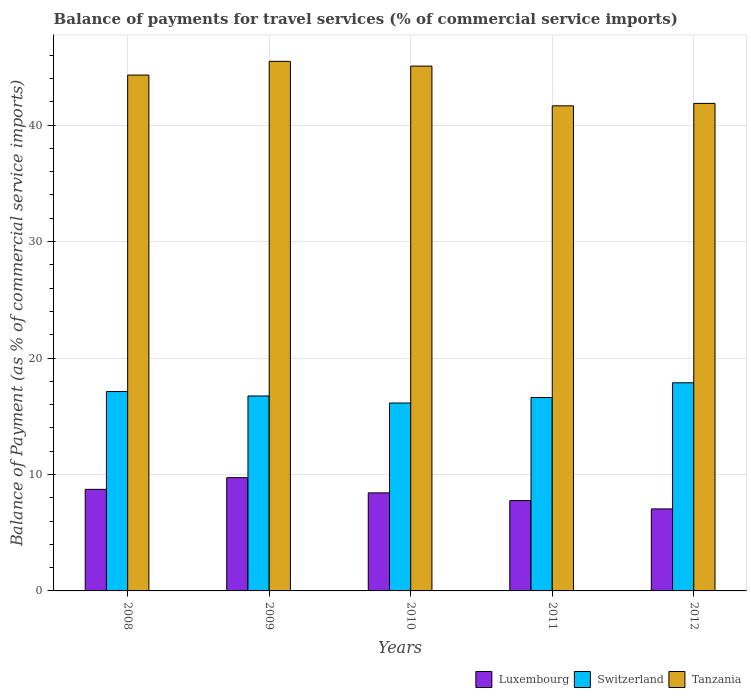How many different coloured bars are there?
Your answer should be very brief. 3. How many groups of bars are there?
Make the answer very short. 5. Are the number of bars on each tick of the X-axis equal?
Keep it short and to the point. Yes. How many bars are there on the 1st tick from the right?
Ensure brevity in your answer.  3. What is the label of the 3rd group of bars from the left?
Your answer should be compact. 2010. In how many cases, is the number of bars for a given year not equal to the number of legend labels?
Give a very brief answer. 0. What is the balance of payments for travel services in Switzerland in 2010?
Give a very brief answer. 16.14. Across all years, what is the maximum balance of payments for travel services in Tanzania?
Your answer should be very brief. 45.48. Across all years, what is the minimum balance of payments for travel services in Luxembourg?
Keep it short and to the point. 7.04. In which year was the balance of payments for travel services in Luxembourg maximum?
Your response must be concise. 2009. In which year was the balance of payments for travel services in Tanzania minimum?
Ensure brevity in your answer.  2011. What is the total balance of payments for travel services in Tanzania in the graph?
Make the answer very short. 218.37. What is the difference between the balance of payments for travel services in Tanzania in 2008 and that in 2011?
Your answer should be compact. 2.64. What is the difference between the balance of payments for travel services in Switzerland in 2010 and the balance of payments for travel services in Tanzania in 2012?
Make the answer very short. -25.73. What is the average balance of payments for travel services in Luxembourg per year?
Your response must be concise. 8.33. In the year 2011, what is the difference between the balance of payments for travel services in Luxembourg and balance of payments for travel services in Tanzania?
Provide a short and direct response. -33.9. In how many years, is the balance of payments for travel services in Switzerland greater than 6 %?
Offer a terse response. 5. What is the ratio of the balance of payments for travel services in Switzerland in 2008 to that in 2010?
Your answer should be very brief. 1.06. Is the balance of payments for travel services in Switzerland in 2009 less than that in 2010?
Your answer should be very brief. No. What is the difference between the highest and the second highest balance of payments for travel services in Luxembourg?
Ensure brevity in your answer.  1. What is the difference between the highest and the lowest balance of payments for travel services in Switzerland?
Your response must be concise. 1.74. In how many years, is the balance of payments for travel services in Luxembourg greater than the average balance of payments for travel services in Luxembourg taken over all years?
Provide a short and direct response. 3. Is the sum of the balance of payments for travel services in Tanzania in 2009 and 2011 greater than the maximum balance of payments for travel services in Switzerland across all years?
Give a very brief answer. Yes. What does the 2nd bar from the left in 2010 represents?
Make the answer very short. Switzerland. What does the 3rd bar from the right in 2008 represents?
Ensure brevity in your answer.  Luxembourg. Are all the bars in the graph horizontal?
Provide a succinct answer. No. How many years are there in the graph?
Offer a very short reply. 5. Are the values on the major ticks of Y-axis written in scientific E-notation?
Keep it short and to the point. No. Does the graph contain grids?
Offer a very short reply. Yes. What is the title of the graph?
Ensure brevity in your answer.  Balance of payments for travel services (% of commercial service imports). What is the label or title of the X-axis?
Make the answer very short. Years. What is the label or title of the Y-axis?
Provide a succinct answer. Balance of Payment (as % of commercial service imports). What is the Balance of Payment (as % of commercial service imports) in Luxembourg in 2008?
Keep it short and to the point. 8.72. What is the Balance of Payment (as % of commercial service imports) of Switzerland in 2008?
Offer a very short reply. 17.12. What is the Balance of Payment (as % of commercial service imports) in Tanzania in 2008?
Your answer should be compact. 44.3. What is the Balance of Payment (as % of commercial service imports) of Luxembourg in 2009?
Provide a succinct answer. 9.73. What is the Balance of Payment (as % of commercial service imports) in Switzerland in 2009?
Your response must be concise. 16.74. What is the Balance of Payment (as % of commercial service imports) in Tanzania in 2009?
Offer a very short reply. 45.48. What is the Balance of Payment (as % of commercial service imports) of Luxembourg in 2010?
Offer a terse response. 8.42. What is the Balance of Payment (as % of commercial service imports) in Switzerland in 2010?
Give a very brief answer. 16.14. What is the Balance of Payment (as % of commercial service imports) of Tanzania in 2010?
Give a very brief answer. 45.07. What is the Balance of Payment (as % of commercial service imports) in Luxembourg in 2011?
Offer a very short reply. 7.76. What is the Balance of Payment (as % of commercial service imports) in Switzerland in 2011?
Offer a terse response. 16.61. What is the Balance of Payment (as % of commercial service imports) of Tanzania in 2011?
Ensure brevity in your answer.  41.66. What is the Balance of Payment (as % of commercial service imports) in Luxembourg in 2012?
Your answer should be compact. 7.04. What is the Balance of Payment (as % of commercial service imports) in Switzerland in 2012?
Your answer should be very brief. 17.87. What is the Balance of Payment (as % of commercial service imports) in Tanzania in 2012?
Make the answer very short. 41.87. Across all years, what is the maximum Balance of Payment (as % of commercial service imports) of Luxembourg?
Offer a very short reply. 9.73. Across all years, what is the maximum Balance of Payment (as % of commercial service imports) of Switzerland?
Offer a terse response. 17.87. Across all years, what is the maximum Balance of Payment (as % of commercial service imports) of Tanzania?
Your answer should be very brief. 45.48. Across all years, what is the minimum Balance of Payment (as % of commercial service imports) of Luxembourg?
Give a very brief answer. 7.04. Across all years, what is the minimum Balance of Payment (as % of commercial service imports) in Switzerland?
Make the answer very short. 16.14. Across all years, what is the minimum Balance of Payment (as % of commercial service imports) in Tanzania?
Keep it short and to the point. 41.66. What is the total Balance of Payment (as % of commercial service imports) of Luxembourg in the graph?
Your response must be concise. 41.67. What is the total Balance of Payment (as % of commercial service imports) in Switzerland in the graph?
Ensure brevity in your answer.  84.48. What is the total Balance of Payment (as % of commercial service imports) in Tanzania in the graph?
Your answer should be very brief. 218.37. What is the difference between the Balance of Payment (as % of commercial service imports) of Luxembourg in 2008 and that in 2009?
Give a very brief answer. -1. What is the difference between the Balance of Payment (as % of commercial service imports) of Switzerland in 2008 and that in 2009?
Offer a terse response. 0.38. What is the difference between the Balance of Payment (as % of commercial service imports) of Tanzania in 2008 and that in 2009?
Make the answer very short. -1.18. What is the difference between the Balance of Payment (as % of commercial service imports) of Luxembourg in 2008 and that in 2010?
Your answer should be compact. 0.3. What is the difference between the Balance of Payment (as % of commercial service imports) in Switzerland in 2008 and that in 2010?
Make the answer very short. 0.98. What is the difference between the Balance of Payment (as % of commercial service imports) in Tanzania in 2008 and that in 2010?
Make the answer very short. -0.77. What is the difference between the Balance of Payment (as % of commercial service imports) of Luxembourg in 2008 and that in 2011?
Offer a very short reply. 0.96. What is the difference between the Balance of Payment (as % of commercial service imports) in Switzerland in 2008 and that in 2011?
Your answer should be very brief. 0.51. What is the difference between the Balance of Payment (as % of commercial service imports) of Tanzania in 2008 and that in 2011?
Your answer should be compact. 2.64. What is the difference between the Balance of Payment (as % of commercial service imports) of Luxembourg in 2008 and that in 2012?
Provide a short and direct response. 1.68. What is the difference between the Balance of Payment (as % of commercial service imports) in Switzerland in 2008 and that in 2012?
Provide a short and direct response. -0.75. What is the difference between the Balance of Payment (as % of commercial service imports) of Tanzania in 2008 and that in 2012?
Your answer should be very brief. 2.43. What is the difference between the Balance of Payment (as % of commercial service imports) of Luxembourg in 2009 and that in 2010?
Your answer should be very brief. 1.31. What is the difference between the Balance of Payment (as % of commercial service imports) of Switzerland in 2009 and that in 2010?
Your answer should be very brief. 0.6. What is the difference between the Balance of Payment (as % of commercial service imports) in Tanzania in 2009 and that in 2010?
Ensure brevity in your answer.  0.41. What is the difference between the Balance of Payment (as % of commercial service imports) in Luxembourg in 2009 and that in 2011?
Your response must be concise. 1.97. What is the difference between the Balance of Payment (as % of commercial service imports) in Switzerland in 2009 and that in 2011?
Your response must be concise. 0.13. What is the difference between the Balance of Payment (as % of commercial service imports) of Tanzania in 2009 and that in 2011?
Keep it short and to the point. 3.82. What is the difference between the Balance of Payment (as % of commercial service imports) of Luxembourg in 2009 and that in 2012?
Ensure brevity in your answer.  2.68. What is the difference between the Balance of Payment (as % of commercial service imports) of Switzerland in 2009 and that in 2012?
Your answer should be very brief. -1.13. What is the difference between the Balance of Payment (as % of commercial service imports) of Tanzania in 2009 and that in 2012?
Provide a short and direct response. 3.61. What is the difference between the Balance of Payment (as % of commercial service imports) in Luxembourg in 2010 and that in 2011?
Ensure brevity in your answer.  0.66. What is the difference between the Balance of Payment (as % of commercial service imports) in Switzerland in 2010 and that in 2011?
Ensure brevity in your answer.  -0.47. What is the difference between the Balance of Payment (as % of commercial service imports) in Tanzania in 2010 and that in 2011?
Your answer should be very brief. 3.41. What is the difference between the Balance of Payment (as % of commercial service imports) of Luxembourg in 2010 and that in 2012?
Give a very brief answer. 1.38. What is the difference between the Balance of Payment (as % of commercial service imports) of Switzerland in 2010 and that in 2012?
Offer a very short reply. -1.74. What is the difference between the Balance of Payment (as % of commercial service imports) in Tanzania in 2010 and that in 2012?
Ensure brevity in your answer.  3.2. What is the difference between the Balance of Payment (as % of commercial service imports) in Luxembourg in 2011 and that in 2012?
Provide a short and direct response. 0.72. What is the difference between the Balance of Payment (as % of commercial service imports) of Switzerland in 2011 and that in 2012?
Offer a very short reply. -1.26. What is the difference between the Balance of Payment (as % of commercial service imports) of Tanzania in 2011 and that in 2012?
Your response must be concise. -0.21. What is the difference between the Balance of Payment (as % of commercial service imports) in Luxembourg in 2008 and the Balance of Payment (as % of commercial service imports) in Switzerland in 2009?
Offer a terse response. -8.02. What is the difference between the Balance of Payment (as % of commercial service imports) in Luxembourg in 2008 and the Balance of Payment (as % of commercial service imports) in Tanzania in 2009?
Your response must be concise. -36.75. What is the difference between the Balance of Payment (as % of commercial service imports) of Switzerland in 2008 and the Balance of Payment (as % of commercial service imports) of Tanzania in 2009?
Your response must be concise. -28.36. What is the difference between the Balance of Payment (as % of commercial service imports) of Luxembourg in 2008 and the Balance of Payment (as % of commercial service imports) of Switzerland in 2010?
Provide a succinct answer. -7.42. What is the difference between the Balance of Payment (as % of commercial service imports) of Luxembourg in 2008 and the Balance of Payment (as % of commercial service imports) of Tanzania in 2010?
Your answer should be very brief. -36.35. What is the difference between the Balance of Payment (as % of commercial service imports) of Switzerland in 2008 and the Balance of Payment (as % of commercial service imports) of Tanzania in 2010?
Ensure brevity in your answer.  -27.95. What is the difference between the Balance of Payment (as % of commercial service imports) of Luxembourg in 2008 and the Balance of Payment (as % of commercial service imports) of Switzerland in 2011?
Your answer should be compact. -7.89. What is the difference between the Balance of Payment (as % of commercial service imports) in Luxembourg in 2008 and the Balance of Payment (as % of commercial service imports) in Tanzania in 2011?
Keep it short and to the point. -32.94. What is the difference between the Balance of Payment (as % of commercial service imports) of Switzerland in 2008 and the Balance of Payment (as % of commercial service imports) of Tanzania in 2011?
Your answer should be compact. -24.54. What is the difference between the Balance of Payment (as % of commercial service imports) of Luxembourg in 2008 and the Balance of Payment (as % of commercial service imports) of Switzerland in 2012?
Your answer should be very brief. -9.15. What is the difference between the Balance of Payment (as % of commercial service imports) in Luxembourg in 2008 and the Balance of Payment (as % of commercial service imports) in Tanzania in 2012?
Provide a succinct answer. -33.14. What is the difference between the Balance of Payment (as % of commercial service imports) in Switzerland in 2008 and the Balance of Payment (as % of commercial service imports) in Tanzania in 2012?
Give a very brief answer. -24.75. What is the difference between the Balance of Payment (as % of commercial service imports) in Luxembourg in 2009 and the Balance of Payment (as % of commercial service imports) in Switzerland in 2010?
Offer a terse response. -6.41. What is the difference between the Balance of Payment (as % of commercial service imports) of Luxembourg in 2009 and the Balance of Payment (as % of commercial service imports) of Tanzania in 2010?
Provide a short and direct response. -35.34. What is the difference between the Balance of Payment (as % of commercial service imports) in Switzerland in 2009 and the Balance of Payment (as % of commercial service imports) in Tanzania in 2010?
Make the answer very short. -28.33. What is the difference between the Balance of Payment (as % of commercial service imports) in Luxembourg in 2009 and the Balance of Payment (as % of commercial service imports) in Switzerland in 2011?
Give a very brief answer. -6.88. What is the difference between the Balance of Payment (as % of commercial service imports) in Luxembourg in 2009 and the Balance of Payment (as % of commercial service imports) in Tanzania in 2011?
Your answer should be very brief. -31.93. What is the difference between the Balance of Payment (as % of commercial service imports) in Switzerland in 2009 and the Balance of Payment (as % of commercial service imports) in Tanzania in 2011?
Give a very brief answer. -24.92. What is the difference between the Balance of Payment (as % of commercial service imports) in Luxembourg in 2009 and the Balance of Payment (as % of commercial service imports) in Switzerland in 2012?
Offer a very short reply. -8.15. What is the difference between the Balance of Payment (as % of commercial service imports) of Luxembourg in 2009 and the Balance of Payment (as % of commercial service imports) of Tanzania in 2012?
Offer a terse response. -32.14. What is the difference between the Balance of Payment (as % of commercial service imports) in Switzerland in 2009 and the Balance of Payment (as % of commercial service imports) in Tanzania in 2012?
Provide a short and direct response. -25.13. What is the difference between the Balance of Payment (as % of commercial service imports) of Luxembourg in 2010 and the Balance of Payment (as % of commercial service imports) of Switzerland in 2011?
Give a very brief answer. -8.19. What is the difference between the Balance of Payment (as % of commercial service imports) in Luxembourg in 2010 and the Balance of Payment (as % of commercial service imports) in Tanzania in 2011?
Keep it short and to the point. -33.24. What is the difference between the Balance of Payment (as % of commercial service imports) in Switzerland in 2010 and the Balance of Payment (as % of commercial service imports) in Tanzania in 2011?
Make the answer very short. -25.52. What is the difference between the Balance of Payment (as % of commercial service imports) of Luxembourg in 2010 and the Balance of Payment (as % of commercial service imports) of Switzerland in 2012?
Give a very brief answer. -9.45. What is the difference between the Balance of Payment (as % of commercial service imports) in Luxembourg in 2010 and the Balance of Payment (as % of commercial service imports) in Tanzania in 2012?
Ensure brevity in your answer.  -33.45. What is the difference between the Balance of Payment (as % of commercial service imports) of Switzerland in 2010 and the Balance of Payment (as % of commercial service imports) of Tanzania in 2012?
Offer a terse response. -25.73. What is the difference between the Balance of Payment (as % of commercial service imports) in Luxembourg in 2011 and the Balance of Payment (as % of commercial service imports) in Switzerland in 2012?
Provide a succinct answer. -10.12. What is the difference between the Balance of Payment (as % of commercial service imports) of Luxembourg in 2011 and the Balance of Payment (as % of commercial service imports) of Tanzania in 2012?
Give a very brief answer. -34.11. What is the difference between the Balance of Payment (as % of commercial service imports) in Switzerland in 2011 and the Balance of Payment (as % of commercial service imports) in Tanzania in 2012?
Ensure brevity in your answer.  -25.26. What is the average Balance of Payment (as % of commercial service imports) in Luxembourg per year?
Give a very brief answer. 8.33. What is the average Balance of Payment (as % of commercial service imports) in Switzerland per year?
Your answer should be compact. 16.9. What is the average Balance of Payment (as % of commercial service imports) in Tanzania per year?
Ensure brevity in your answer.  43.67. In the year 2008, what is the difference between the Balance of Payment (as % of commercial service imports) of Luxembourg and Balance of Payment (as % of commercial service imports) of Switzerland?
Give a very brief answer. -8.4. In the year 2008, what is the difference between the Balance of Payment (as % of commercial service imports) of Luxembourg and Balance of Payment (as % of commercial service imports) of Tanzania?
Offer a very short reply. -35.58. In the year 2008, what is the difference between the Balance of Payment (as % of commercial service imports) of Switzerland and Balance of Payment (as % of commercial service imports) of Tanzania?
Your response must be concise. -27.18. In the year 2009, what is the difference between the Balance of Payment (as % of commercial service imports) of Luxembourg and Balance of Payment (as % of commercial service imports) of Switzerland?
Keep it short and to the point. -7.01. In the year 2009, what is the difference between the Balance of Payment (as % of commercial service imports) of Luxembourg and Balance of Payment (as % of commercial service imports) of Tanzania?
Make the answer very short. -35.75. In the year 2009, what is the difference between the Balance of Payment (as % of commercial service imports) of Switzerland and Balance of Payment (as % of commercial service imports) of Tanzania?
Make the answer very short. -28.74. In the year 2010, what is the difference between the Balance of Payment (as % of commercial service imports) in Luxembourg and Balance of Payment (as % of commercial service imports) in Switzerland?
Provide a succinct answer. -7.72. In the year 2010, what is the difference between the Balance of Payment (as % of commercial service imports) of Luxembourg and Balance of Payment (as % of commercial service imports) of Tanzania?
Give a very brief answer. -36.65. In the year 2010, what is the difference between the Balance of Payment (as % of commercial service imports) of Switzerland and Balance of Payment (as % of commercial service imports) of Tanzania?
Your response must be concise. -28.93. In the year 2011, what is the difference between the Balance of Payment (as % of commercial service imports) of Luxembourg and Balance of Payment (as % of commercial service imports) of Switzerland?
Keep it short and to the point. -8.85. In the year 2011, what is the difference between the Balance of Payment (as % of commercial service imports) in Luxembourg and Balance of Payment (as % of commercial service imports) in Tanzania?
Offer a very short reply. -33.9. In the year 2011, what is the difference between the Balance of Payment (as % of commercial service imports) in Switzerland and Balance of Payment (as % of commercial service imports) in Tanzania?
Make the answer very short. -25.05. In the year 2012, what is the difference between the Balance of Payment (as % of commercial service imports) in Luxembourg and Balance of Payment (as % of commercial service imports) in Switzerland?
Your response must be concise. -10.83. In the year 2012, what is the difference between the Balance of Payment (as % of commercial service imports) in Luxembourg and Balance of Payment (as % of commercial service imports) in Tanzania?
Ensure brevity in your answer.  -34.82. In the year 2012, what is the difference between the Balance of Payment (as % of commercial service imports) in Switzerland and Balance of Payment (as % of commercial service imports) in Tanzania?
Your answer should be compact. -23.99. What is the ratio of the Balance of Payment (as % of commercial service imports) of Luxembourg in 2008 to that in 2009?
Your answer should be compact. 0.9. What is the ratio of the Balance of Payment (as % of commercial service imports) in Switzerland in 2008 to that in 2009?
Your response must be concise. 1.02. What is the ratio of the Balance of Payment (as % of commercial service imports) in Tanzania in 2008 to that in 2009?
Your answer should be compact. 0.97. What is the ratio of the Balance of Payment (as % of commercial service imports) of Luxembourg in 2008 to that in 2010?
Your answer should be very brief. 1.04. What is the ratio of the Balance of Payment (as % of commercial service imports) of Switzerland in 2008 to that in 2010?
Ensure brevity in your answer.  1.06. What is the ratio of the Balance of Payment (as % of commercial service imports) of Tanzania in 2008 to that in 2010?
Offer a terse response. 0.98. What is the ratio of the Balance of Payment (as % of commercial service imports) of Luxembourg in 2008 to that in 2011?
Make the answer very short. 1.12. What is the ratio of the Balance of Payment (as % of commercial service imports) in Switzerland in 2008 to that in 2011?
Provide a short and direct response. 1.03. What is the ratio of the Balance of Payment (as % of commercial service imports) in Tanzania in 2008 to that in 2011?
Give a very brief answer. 1.06. What is the ratio of the Balance of Payment (as % of commercial service imports) in Luxembourg in 2008 to that in 2012?
Keep it short and to the point. 1.24. What is the ratio of the Balance of Payment (as % of commercial service imports) in Switzerland in 2008 to that in 2012?
Ensure brevity in your answer.  0.96. What is the ratio of the Balance of Payment (as % of commercial service imports) of Tanzania in 2008 to that in 2012?
Make the answer very short. 1.06. What is the ratio of the Balance of Payment (as % of commercial service imports) in Luxembourg in 2009 to that in 2010?
Keep it short and to the point. 1.16. What is the ratio of the Balance of Payment (as % of commercial service imports) of Switzerland in 2009 to that in 2010?
Your response must be concise. 1.04. What is the ratio of the Balance of Payment (as % of commercial service imports) of Luxembourg in 2009 to that in 2011?
Make the answer very short. 1.25. What is the ratio of the Balance of Payment (as % of commercial service imports) of Switzerland in 2009 to that in 2011?
Offer a very short reply. 1.01. What is the ratio of the Balance of Payment (as % of commercial service imports) in Tanzania in 2009 to that in 2011?
Provide a short and direct response. 1.09. What is the ratio of the Balance of Payment (as % of commercial service imports) of Luxembourg in 2009 to that in 2012?
Give a very brief answer. 1.38. What is the ratio of the Balance of Payment (as % of commercial service imports) of Switzerland in 2009 to that in 2012?
Provide a short and direct response. 0.94. What is the ratio of the Balance of Payment (as % of commercial service imports) of Tanzania in 2009 to that in 2012?
Offer a terse response. 1.09. What is the ratio of the Balance of Payment (as % of commercial service imports) of Luxembourg in 2010 to that in 2011?
Your answer should be compact. 1.09. What is the ratio of the Balance of Payment (as % of commercial service imports) in Switzerland in 2010 to that in 2011?
Ensure brevity in your answer.  0.97. What is the ratio of the Balance of Payment (as % of commercial service imports) of Tanzania in 2010 to that in 2011?
Offer a terse response. 1.08. What is the ratio of the Balance of Payment (as % of commercial service imports) in Luxembourg in 2010 to that in 2012?
Provide a short and direct response. 1.2. What is the ratio of the Balance of Payment (as % of commercial service imports) of Switzerland in 2010 to that in 2012?
Your answer should be very brief. 0.9. What is the ratio of the Balance of Payment (as % of commercial service imports) of Tanzania in 2010 to that in 2012?
Keep it short and to the point. 1.08. What is the ratio of the Balance of Payment (as % of commercial service imports) in Luxembourg in 2011 to that in 2012?
Provide a succinct answer. 1.1. What is the ratio of the Balance of Payment (as % of commercial service imports) in Switzerland in 2011 to that in 2012?
Provide a succinct answer. 0.93. What is the difference between the highest and the second highest Balance of Payment (as % of commercial service imports) in Switzerland?
Ensure brevity in your answer.  0.75. What is the difference between the highest and the second highest Balance of Payment (as % of commercial service imports) in Tanzania?
Your answer should be compact. 0.41. What is the difference between the highest and the lowest Balance of Payment (as % of commercial service imports) of Luxembourg?
Your response must be concise. 2.68. What is the difference between the highest and the lowest Balance of Payment (as % of commercial service imports) of Switzerland?
Ensure brevity in your answer.  1.74. What is the difference between the highest and the lowest Balance of Payment (as % of commercial service imports) in Tanzania?
Offer a terse response. 3.82. 